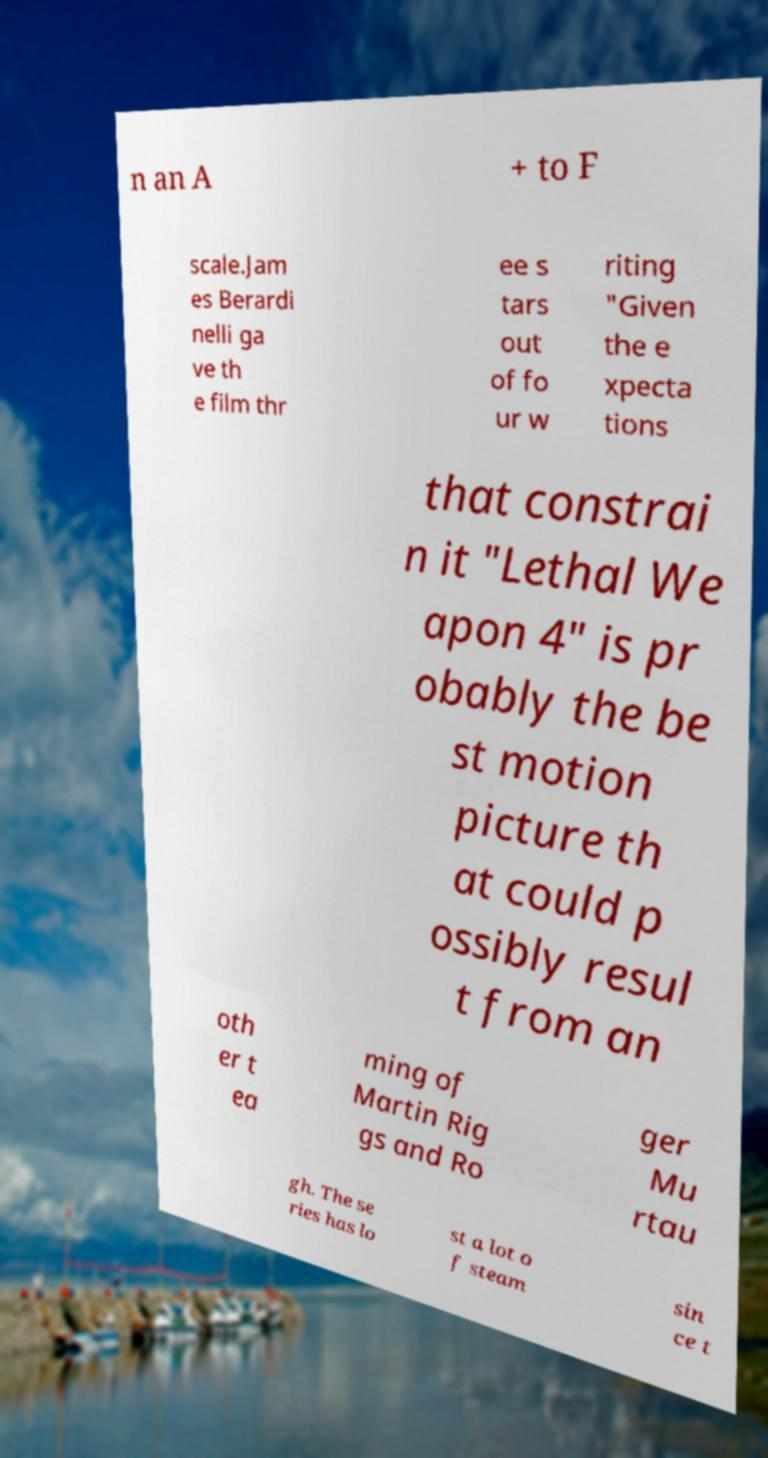Can you accurately transcribe the text from the provided image for me? n an A + to F scale.Jam es Berardi nelli ga ve th e film thr ee s tars out of fo ur w riting "Given the e xpecta tions that constrai n it "Lethal We apon 4" is pr obably the be st motion picture th at could p ossibly resul t from an oth er t ea ming of Martin Rig gs and Ro ger Mu rtau gh. The se ries has lo st a lot o f steam sin ce t 